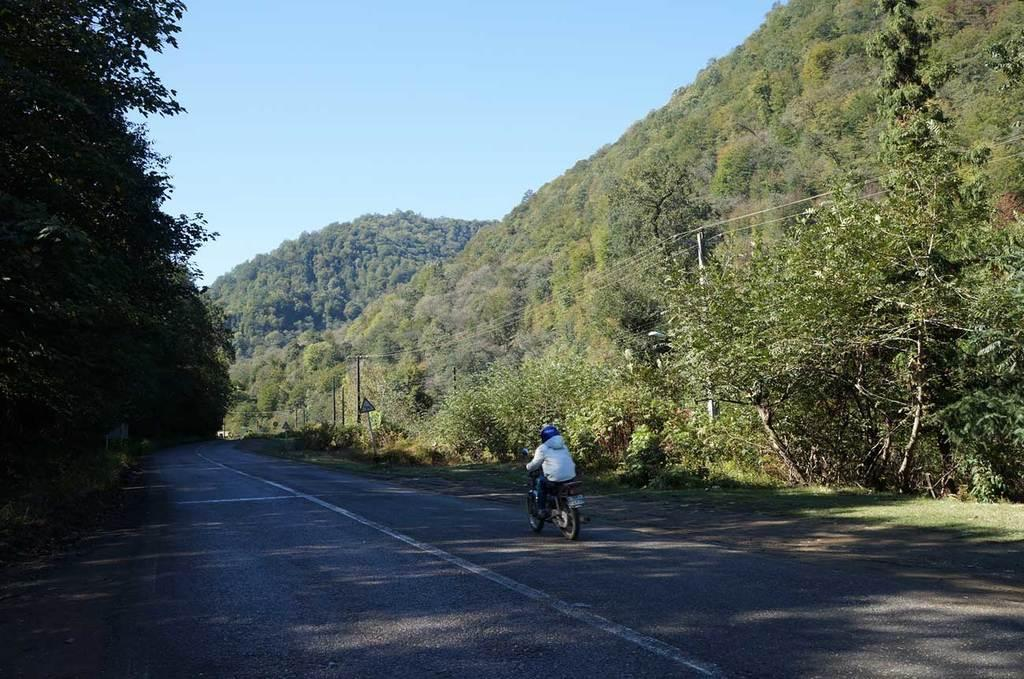What is the person in the image doing? The person is riding a bike in the image. Where is the person riding the bike? The person is on the road. What can be seen on either side of the road? There are trees and sign boards on either side of the road. What else can be seen on either side of the road? There are electrical poles with cables on them on either side of the road. What is the manager's role in the image? There is no manager present in the image. What is the person's desire while riding the bike in the image? The image does not provide information about the person's desires or intentions while riding the bike. 